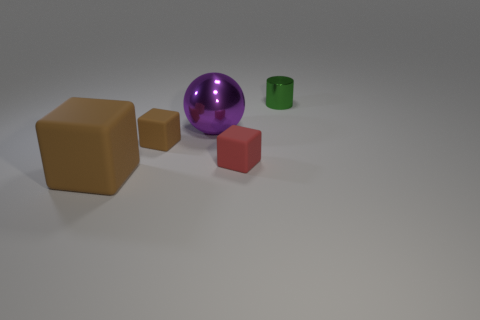Does the big brown rubber object have the same shape as the red thing?
Make the answer very short. Yes. There is a green thing that is the same material as the large purple object; what shape is it?
Your answer should be very brief. Cylinder. How many large things are either brown objects or shiny spheres?
Offer a terse response. 2. Is there a tiny brown object that is to the right of the big thing in front of the large metallic thing?
Keep it short and to the point. Yes. Are any gray cubes visible?
Your answer should be very brief. No. What color is the tiny matte block on the right side of the tiny matte thing behind the tiny red rubber cube?
Your answer should be compact. Red. What material is the other large thing that is the same shape as the red matte object?
Your answer should be compact. Rubber. What number of other balls are the same size as the purple shiny ball?
Offer a terse response. 0. The red object that is made of the same material as the tiny brown object is what size?
Give a very brief answer. Small. How many other small rubber objects have the same shape as the tiny red thing?
Your response must be concise. 1. 